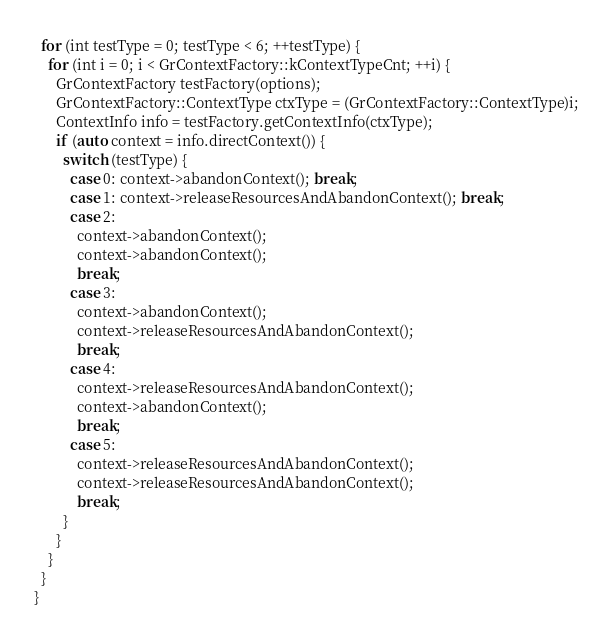<code> <loc_0><loc_0><loc_500><loc_500><_C++_>  for (int testType = 0; testType < 6; ++testType) {
    for (int i = 0; i < GrContextFactory::kContextTypeCnt; ++i) {
      GrContextFactory testFactory(options);
      GrContextFactory::ContextType ctxType = (GrContextFactory::ContextType)i;
      ContextInfo info = testFactory.getContextInfo(ctxType);
      if (auto context = info.directContext()) {
        switch (testType) {
          case 0: context->abandonContext(); break;
          case 1: context->releaseResourcesAndAbandonContext(); break;
          case 2:
            context->abandonContext();
            context->abandonContext();
            break;
          case 3:
            context->abandonContext();
            context->releaseResourcesAndAbandonContext();
            break;
          case 4:
            context->releaseResourcesAndAbandonContext();
            context->abandonContext();
            break;
          case 5:
            context->releaseResourcesAndAbandonContext();
            context->releaseResourcesAndAbandonContext();
            break;
        }
      }
    }
  }
}
</code> 